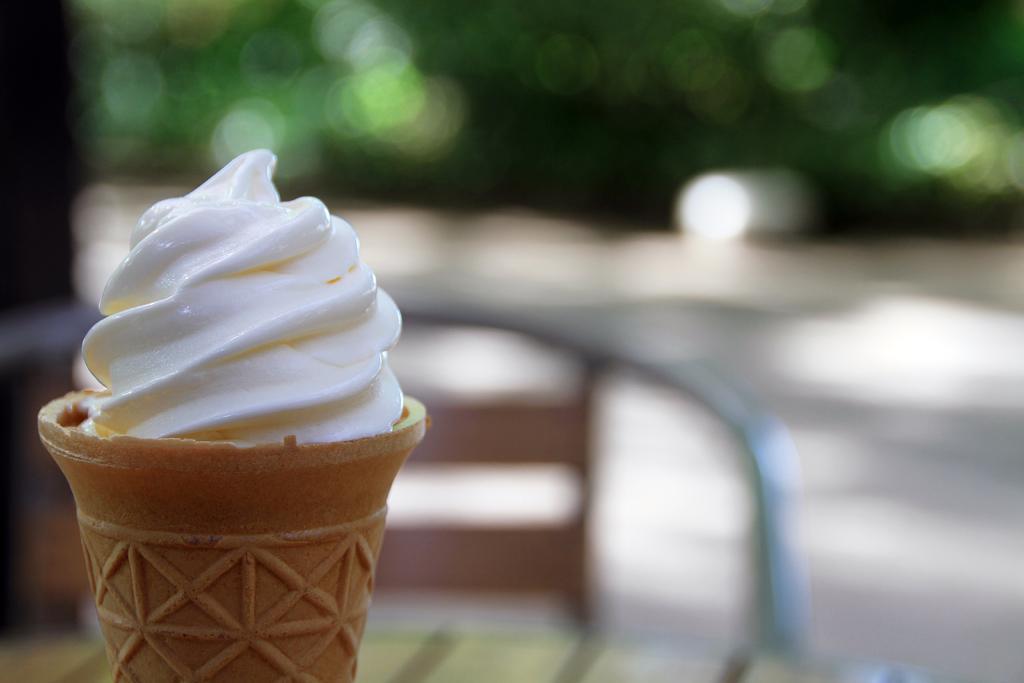Can you describe this image briefly? In this picture we can see an ice cream, table, and a chair. There is a blur background. 